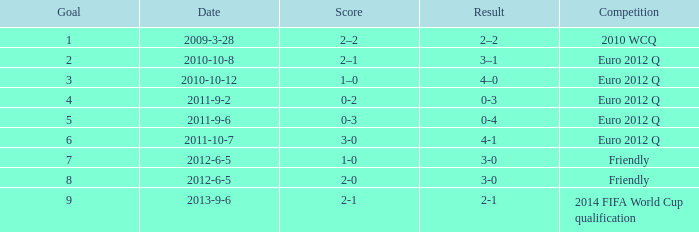How many goals when the score is 3-0 in the euro 2012 q? 1.0. 